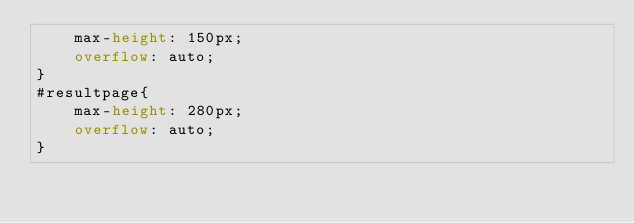Convert code to text. <code><loc_0><loc_0><loc_500><loc_500><_CSS_>    max-height: 150px;
    overflow: auto;
}
#resultpage{
    max-height: 280px;
    overflow: auto;
}
</code> 